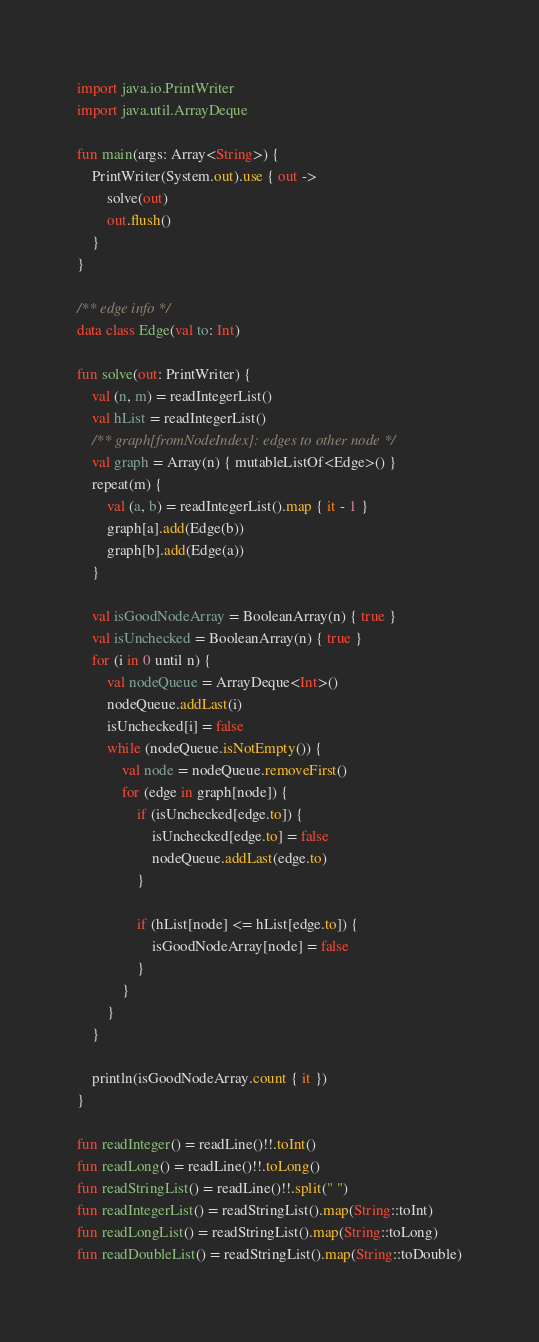Convert code to text. <code><loc_0><loc_0><loc_500><loc_500><_Kotlin_>import java.io.PrintWriter
import java.util.ArrayDeque

fun main(args: Array<String>) {
    PrintWriter(System.out).use { out ->
        solve(out)
        out.flush()
    }
}

/** edge info */
data class Edge(val to: Int)

fun solve(out: PrintWriter) {
    val (n, m) = readIntegerList()
    val hList = readIntegerList()
    /** graph[fromNodeIndex]: edges to other node */
    val graph = Array(n) { mutableListOf<Edge>() }
    repeat(m) {
        val (a, b) = readIntegerList().map { it - 1 }
        graph[a].add(Edge(b))
        graph[b].add(Edge(a))
    }

    val isGoodNodeArray = BooleanArray(n) { true }
    val isUnchecked = BooleanArray(n) { true }
    for (i in 0 until n) {
        val nodeQueue = ArrayDeque<Int>()
        nodeQueue.addLast(i)
        isUnchecked[i] = false
        while (nodeQueue.isNotEmpty()) {
            val node = nodeQueue.removeFirst()
            for (edge in graph[node]) {
                if (isUnchecked[edge.to]) {
                    isUnchecked[edge.to] = false
                    nodeQueue.addLast(edge.to)
                }

                if (hList[node] <= hList[edge.to]) {
                    isGoodNodeArray[node] = false
                }
            }
        }
    }

    println(isGoodNodeArray.count { it })
}

fun readInteger() = readLine()!!.toInt()
fun readLong() = readLine()!!.toLong()
fun readStringList() = readLine()!!.split(" ")
fun readIntegerList() = readStringList().map(String::toInt)
fun readLongList() = readStringList().map(String::toLong)
fun readDoubleList() = readStringList().map(String::toDouble)
</code> 